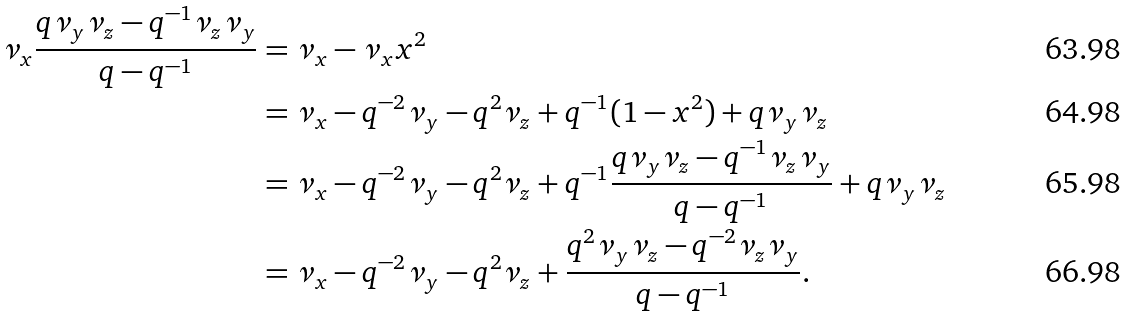<formula> <loc_0><loc_0><loc_500><loc_500>\nu _ { x } \frac { q \nu _ { y } \nu _ { z } - q ^ { - 1 } \nu _ { z } \nu _ { y } } { q - q ^ { - 1 } } & = \nu _ { x } - \nu _ { x } x ^ { 2 } \\ & = \nu _ { x } - q ^ { - 2 } \nu _ { y } - q ^ { 2 } \nu _ { z } + q ^ { - 1 } ( 1 - x ^ { 2 } ) + q \nu _ { y } \nu _ { z } \\ & = \nu _ { x } - q ^ { - 2 } \nu _ { y } - q ^ { 2 } \nu _ { z } + q ^ { - 1 } \frac { q \nu _ { y } \nu _ { z } - q ^ { - 1 } \nu _ { z } \nu _ { y } } { q - q ^ { - 1 } } + q \nu _ { y } \nu _ { z } \\ & = \nu _ { x } - q ^ { - 2 } \nu _ { y } - q ^ { 2 } \nu _ { z } + \frac { q ^ { 2 } \nu _ { y } \nu _ { z } - q ^ { - 2 } \nu _ { z } \nu _ { y } } { q - q ^ { - 1 } } .</formula> 